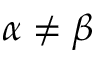<formula> <loc_0><loc_0><loc_500><loc_500>\alpha \neq \beta</formula> 